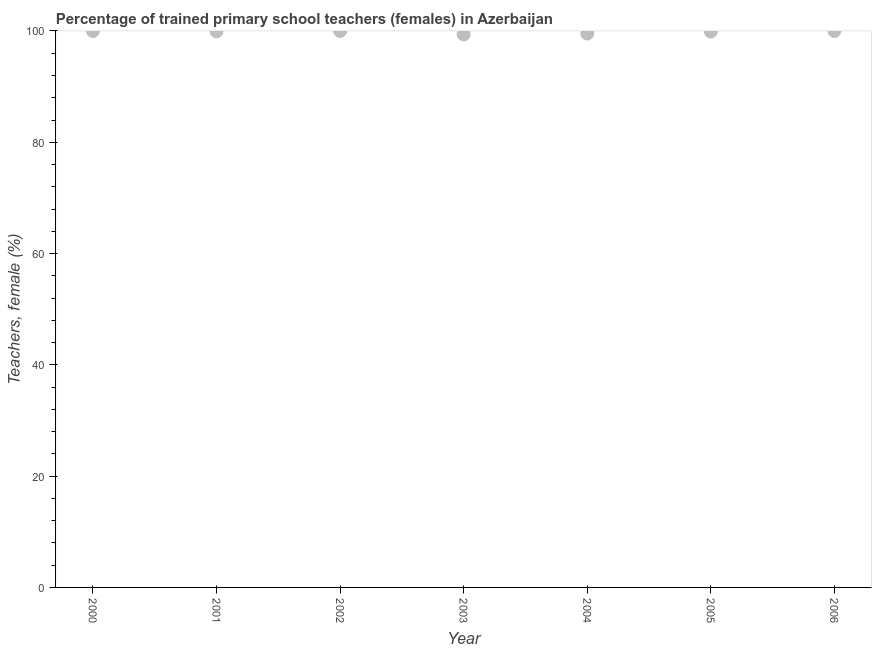What is the percentage of trained female teachers in 2001?
Your response must be concise. 99.94. Across all years, what is the maximum percentage of trained female teachers?
Your answer should be compact. 100. Across all years, what is the minimum percentage of trained female teachers?
Offer a very short reply. 99.38. In which year was the percentage of trained female teachers minimum?
Your answer should be very brief. 2003. What is the sum of the percentage of trained female teachers?
Keep it short and to the point. 698.74. What is the difference between the percentage of trained female teachers in 2001 and 2005?
Give a very brief answer. 0.04. What is the average percentage of trained female teachers per year?
Your response must be concise. 99.82. What is the median percentage of trained female teachers?
Keep it short and to the point. 99.94. Do a majority of the years between 2006 and 2002 (inclusive) have percentage of trained female teachers greater than 72 %?
Offer a very short reply. Yes. What is the ratio of the percentage of trained female teachers in 2001 to that in 2006?
Your response must be concise. 1. Is the percentage of trained female teachers in 2001 less than that in 2003?
Ensure brevity in your answer.  No. Is the difference between the percentage of trained female teachers in 2002 and 2004 greater than the difference between any two years?
Your response must be concise. No. What is the difference between the highest and the lowest percentage of trained female teachers?
Keep it short and to the point. 0.62. Does the percentage of trained female teachers monotonically increase over the years?
Provide a short and direct response. No. How many years are there in the graph?
Make the answer very short. 7. Are the values on the major ticks of Y-axis written in scientific E-notation?
Your answer should be very brief. No. Does the graph contain any zero values?
Ensure brevity in your answer.  No. Does the graph contain grids?
Your answer should be very brief. No. What is the title of the graph?
Your response must be concise. Percentage of trained primary school teachers (females) in Azerbaijan. What is the label or title of the Y-axis?
Keep it short and to the point. Teachers, female (%). What is the Teachers, female (%) in 2000?
Ensure brevity in your answer.  99.98. What is the Teachers, female (%) in 2001?
Provide a short and direct response. 99.94. What is the Teachers, female (%) in 2002?
Your answer should be very brief. 100. What is the Teachers, female (%) in 2003?
Give a very brief answer. 99.38. What is the Teachers, female (%) in 2004?
Offer a very short reply. 99.53. What is the Teachers, female (%) in 2005?
Your answer should be compact. 99.9. What is the difference between the Teachers, female (%) in 2000 and 2001?
Provide a succinct answer. 0.04. What is the difference between the Teachers, female (%) in 2000 and 2002?
Make the answer very short. -0.02. What is the difference between the Teachers, female (%) in 2000 and 2003?
Provide a succinct answer. 0.61. What is the difference between the Teachers, female (%) in 2000 and 2004?
Provide a succinct answer. 0.45. What is the difference between the Teachers, female (%) in 2000 and 2005?
Provide a succinct answer. 0.08. What is the difference between the Teachers, female (%) in 2000 and 2006?
Ensure brevity in your answer.  -0.02. What is the difference between the Teachers, female (%) in 2001 and 2002?
Make the answer very short. -0.06. What is the difference between the Teachers, female (%) in 2001 and 2003?
Offer a terse response. 0.56. What is the difference between the Teachers, female (%) in 2001 and 2004?
Your response must be concise. 0.41. What is the difference between the Teachers, female (%) in 2001 and 2005?
Keep it short and to the point. 0.04. What is the difference between the Teachers, female (%) in 2001 and 2006?
Your answer should be compact. -0.06. What is the difference between the Teachers, female (%) in 2002 and 2003?
Make the answer very short. 0.62. What is the difference between the Teachers, female (%) in 2002 and 2004?
Provide a succinct answer. 0.47. What is the difference between the Teachers, female (%) in 2002 and 2005?
Give a very brief answer. 0.1. What is the difference between the Teachers, female (%) in 2002 and 2006?
Your answer should be compact. 0. What is the difference between the Teachers, female (%) in 2003 and 2004?
Ensure brevity in your answer.  -0.16. What is the difference between the Teachers, female (%) in 2003 and 2005?
Your answer should be very brief. -0.53. What is the difference between the Teachers, female (%) in 2003 and 2006?
Your answer should be compact. -0.62. What is the difference between the Teachers, female (%) in 2004 and 2005?
Your answer should be very brief. -0.37. What is the difference between the Teachers, female (%) in 2004 and 2006?
Your response must be concise. -0.47. What is the difference between the Teachers, female (%) in 2005 and 2006?
Offer a very short reply. -0.1. What is the ratio of the Teachers, female (%) in 2000 to that in 2001?
Your response must be concise. 1. What is the ratio of the Teachers, female (%) in 2000 to that in 2004?
Keep it short and to the point. 1. What is the ratio of the Teachers, female (%) in 2000 to that in 2005?
Ensure brevity in your answer.  1. What is the ratio of the Teachers, female (%) in 2002 to that in 2003?
Keep it short and to the point. 1.01. What is the ratio of the Teachers, female (%) in 2002 to that in 2005?
Offer a very short reply. 1. What is the ratio of the Teachers, female (%) in 2002 to that in 2006?
Ensure brevity in your answer.  1. What is the ratio of the Teachers, female (%) in 2004 to that in 2005?
Offer a very short reply. 1. What is the ratio of the Teachers, female (%) in 2004 to that in 2006?
Ensure brevity in your answer.  0.99. What is the ratio of the Teachers, female (%) in 2005 to that in 2006?
Offer a very short reply. 1. 